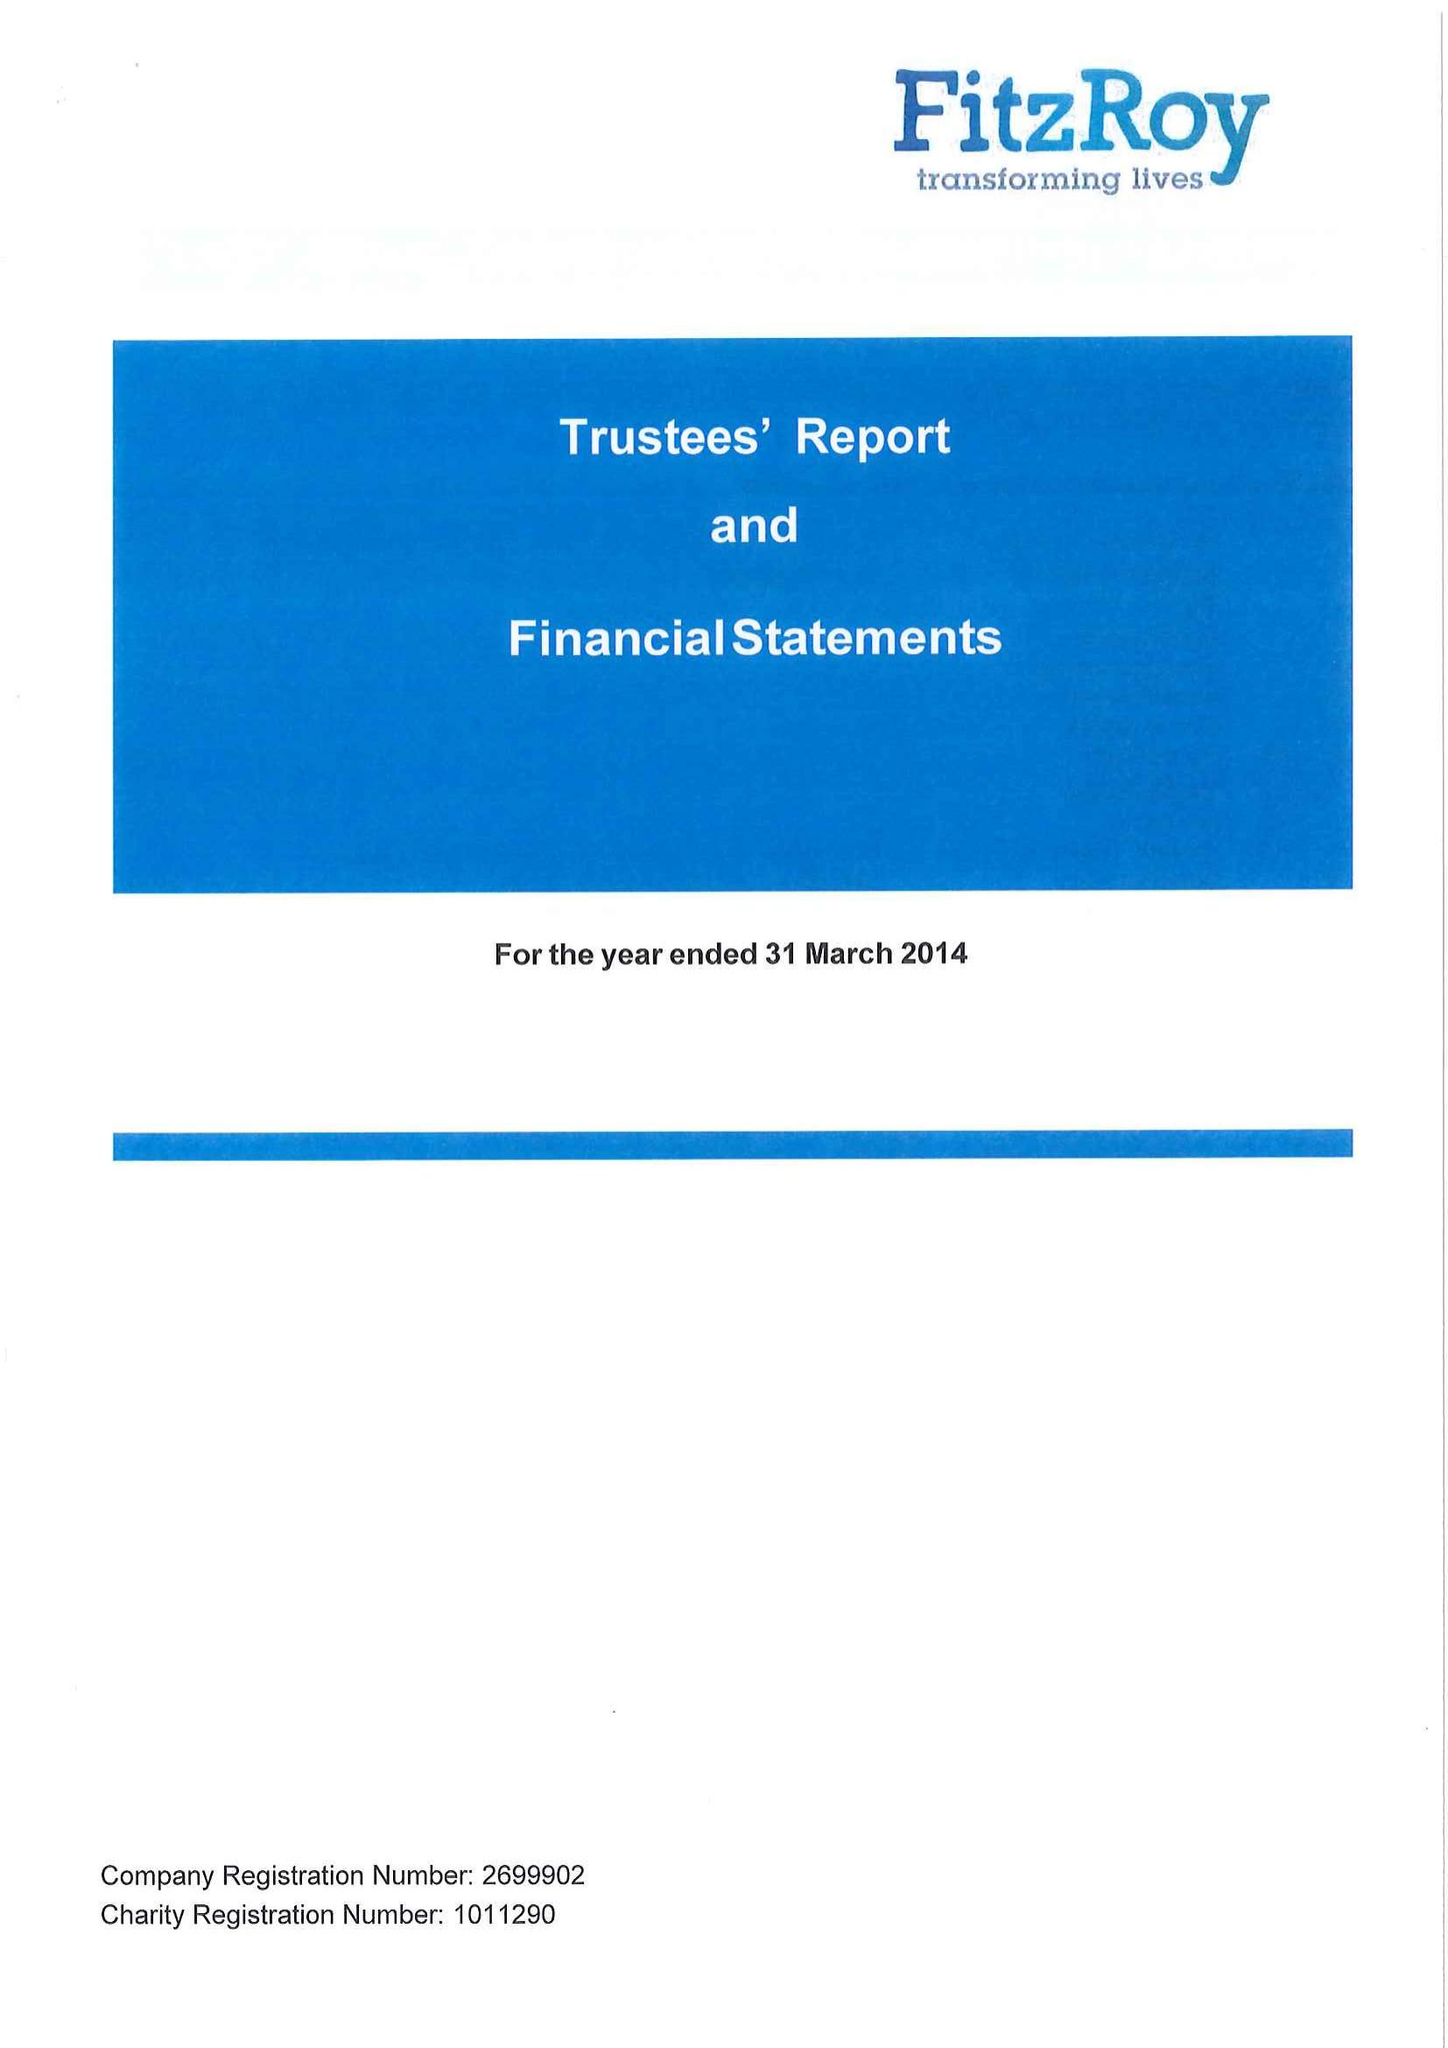What is the value for the address__postcode?
Answer the question using a single word or phrase. GU32 3JY 